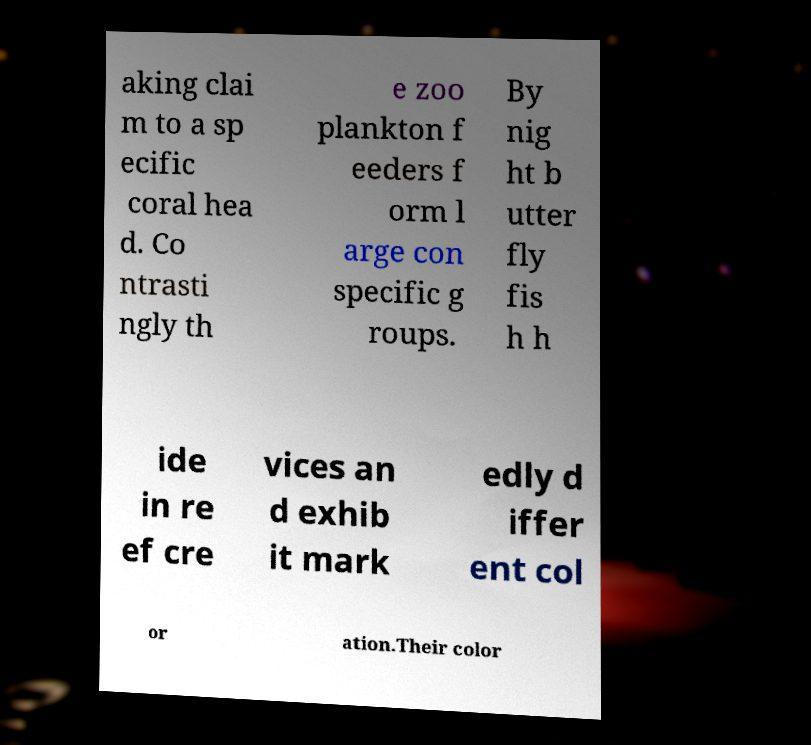Can you accurately transcribe the text from the provided image for me? aking clai m to a sp ecific coral hea d. Co ntrasti ngly th e zoo plankton f eeders f orm l arge con specific g roups. By nig ht b utter fly fis h h ide in re ef cre vices an d exhib it mark edly d iffer ent col or ation.Their color 